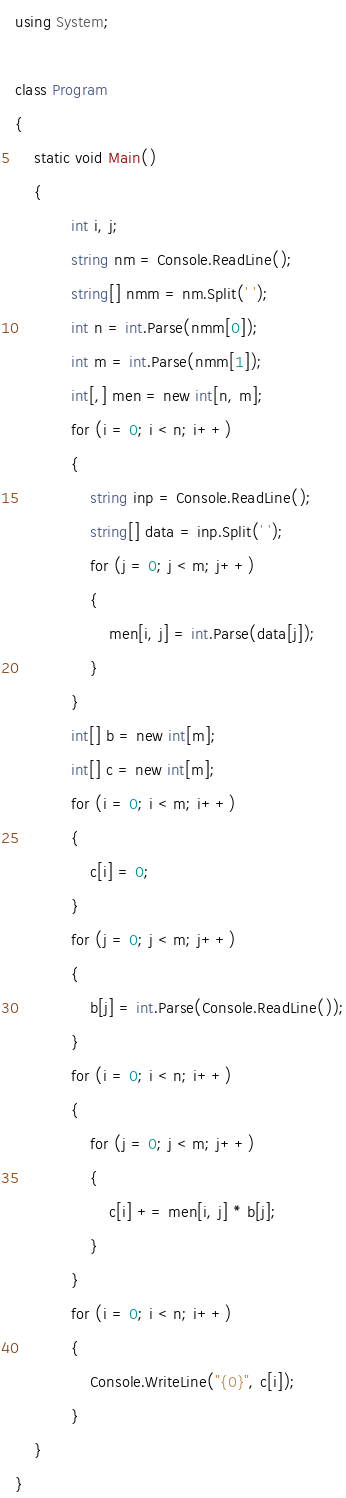Convert code to text. <code><loc_0><loc_0><loc_500><loc_500><_C#_>using System;

class Program
{
    static void Main()
    {
            int i, j;
            string nm = Console.ReadLine();
            string[] nmm = nm.Split(' ');
            int n = int.Parse(nmm[0]);
            int m = int.Parse(nmm[1]);
            int[,] men = new int[n, m];
            for (i = 0; i < n; i++)
            {
                string inp = Console.ReadLine();
                string[] data = inp.Split(' ');
                for (j = 0; j < m; j++)
                {
                    men[i, j] = int.Parse(data[j]);
                }
            }
            int[] b = new int[m];
            int[] c = new int[m];
            for (i = 0; i < m; i++)
            {
                c[i] = 0;
            }
            for (j = 0; j < m; j++)
            {
                b[j] = int.Parse(Console.ReadLine());
            }
            for (i = 0; i < n; i++)
            {
                for (j = 0; j < m; j++)
                {
                    c[i] += men[i, j] * b[j];
                }
            }
            for (i = 0; i < n; i++)
            {
                Console.WriteLine("{0}", c[i]);
            }
    }
}
</code> 